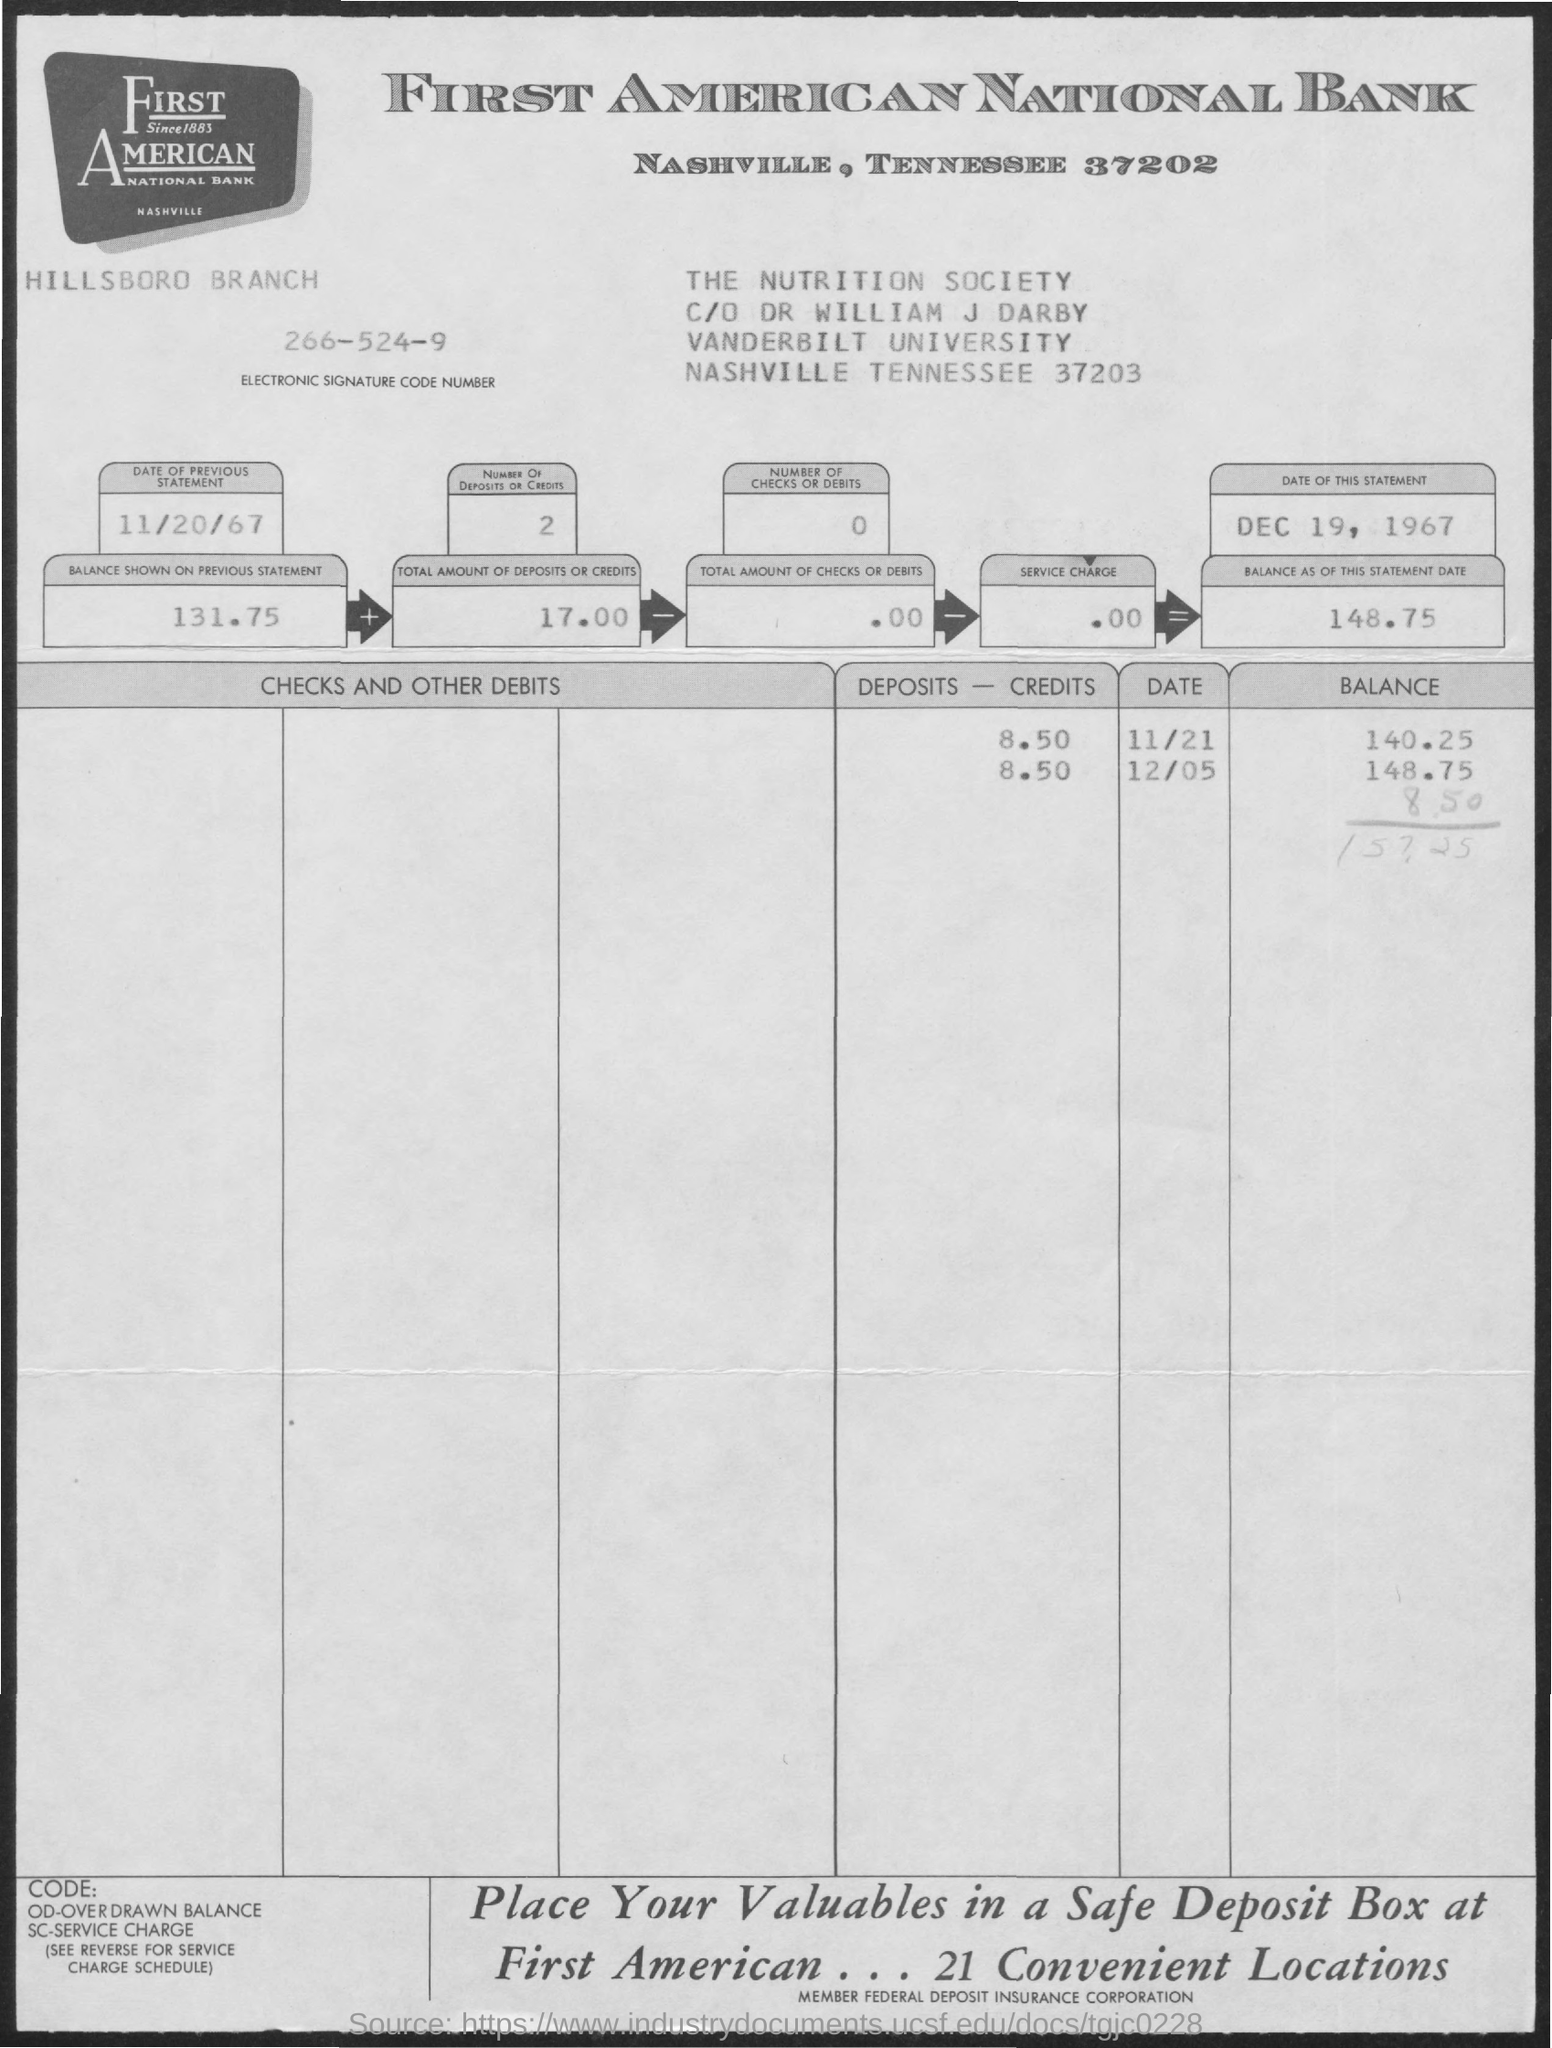What is the electronic signature code number?
Offer a very short reply. 266-524-9. What is the total number of deposits/credits?
Offer a very short reply. 2. What is the total number of checks or debits?
Provide a short and direct response. 0. What is the date of the previous statement?
Provide a succinct answer. 11/20/67. What is the date of this statement?
Ensure brevity in your answer.  Dec 19, 1967. What is the balance shown in the previous statement?
Offer a terse response. 131.75. What is the total amount of deposits or credits?
Your response must be concise. 17.00. What is the total amount of checks or debits?
Keep it short and to the point. .00. What is the service charge?
Keep it short and to the point. .00. 